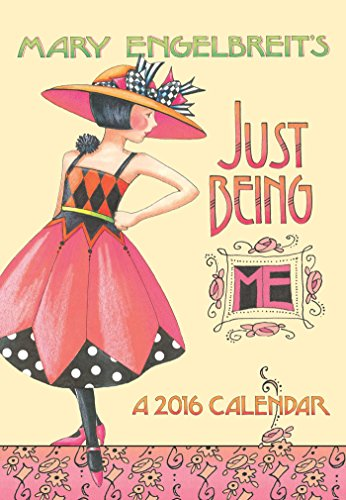Who wrote this book? The book 'Mary Engelbreit 2016 Monthly Pocket Planner' was authored by Mary Engelbreit, a well-known illustrator and graphic artist. 